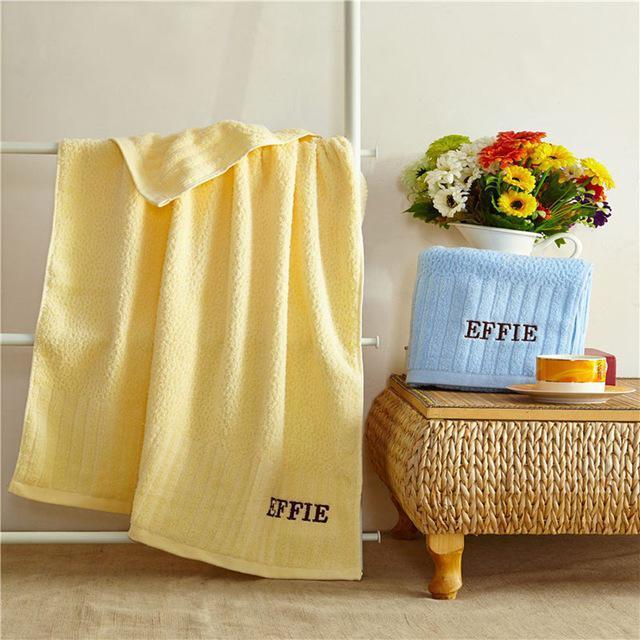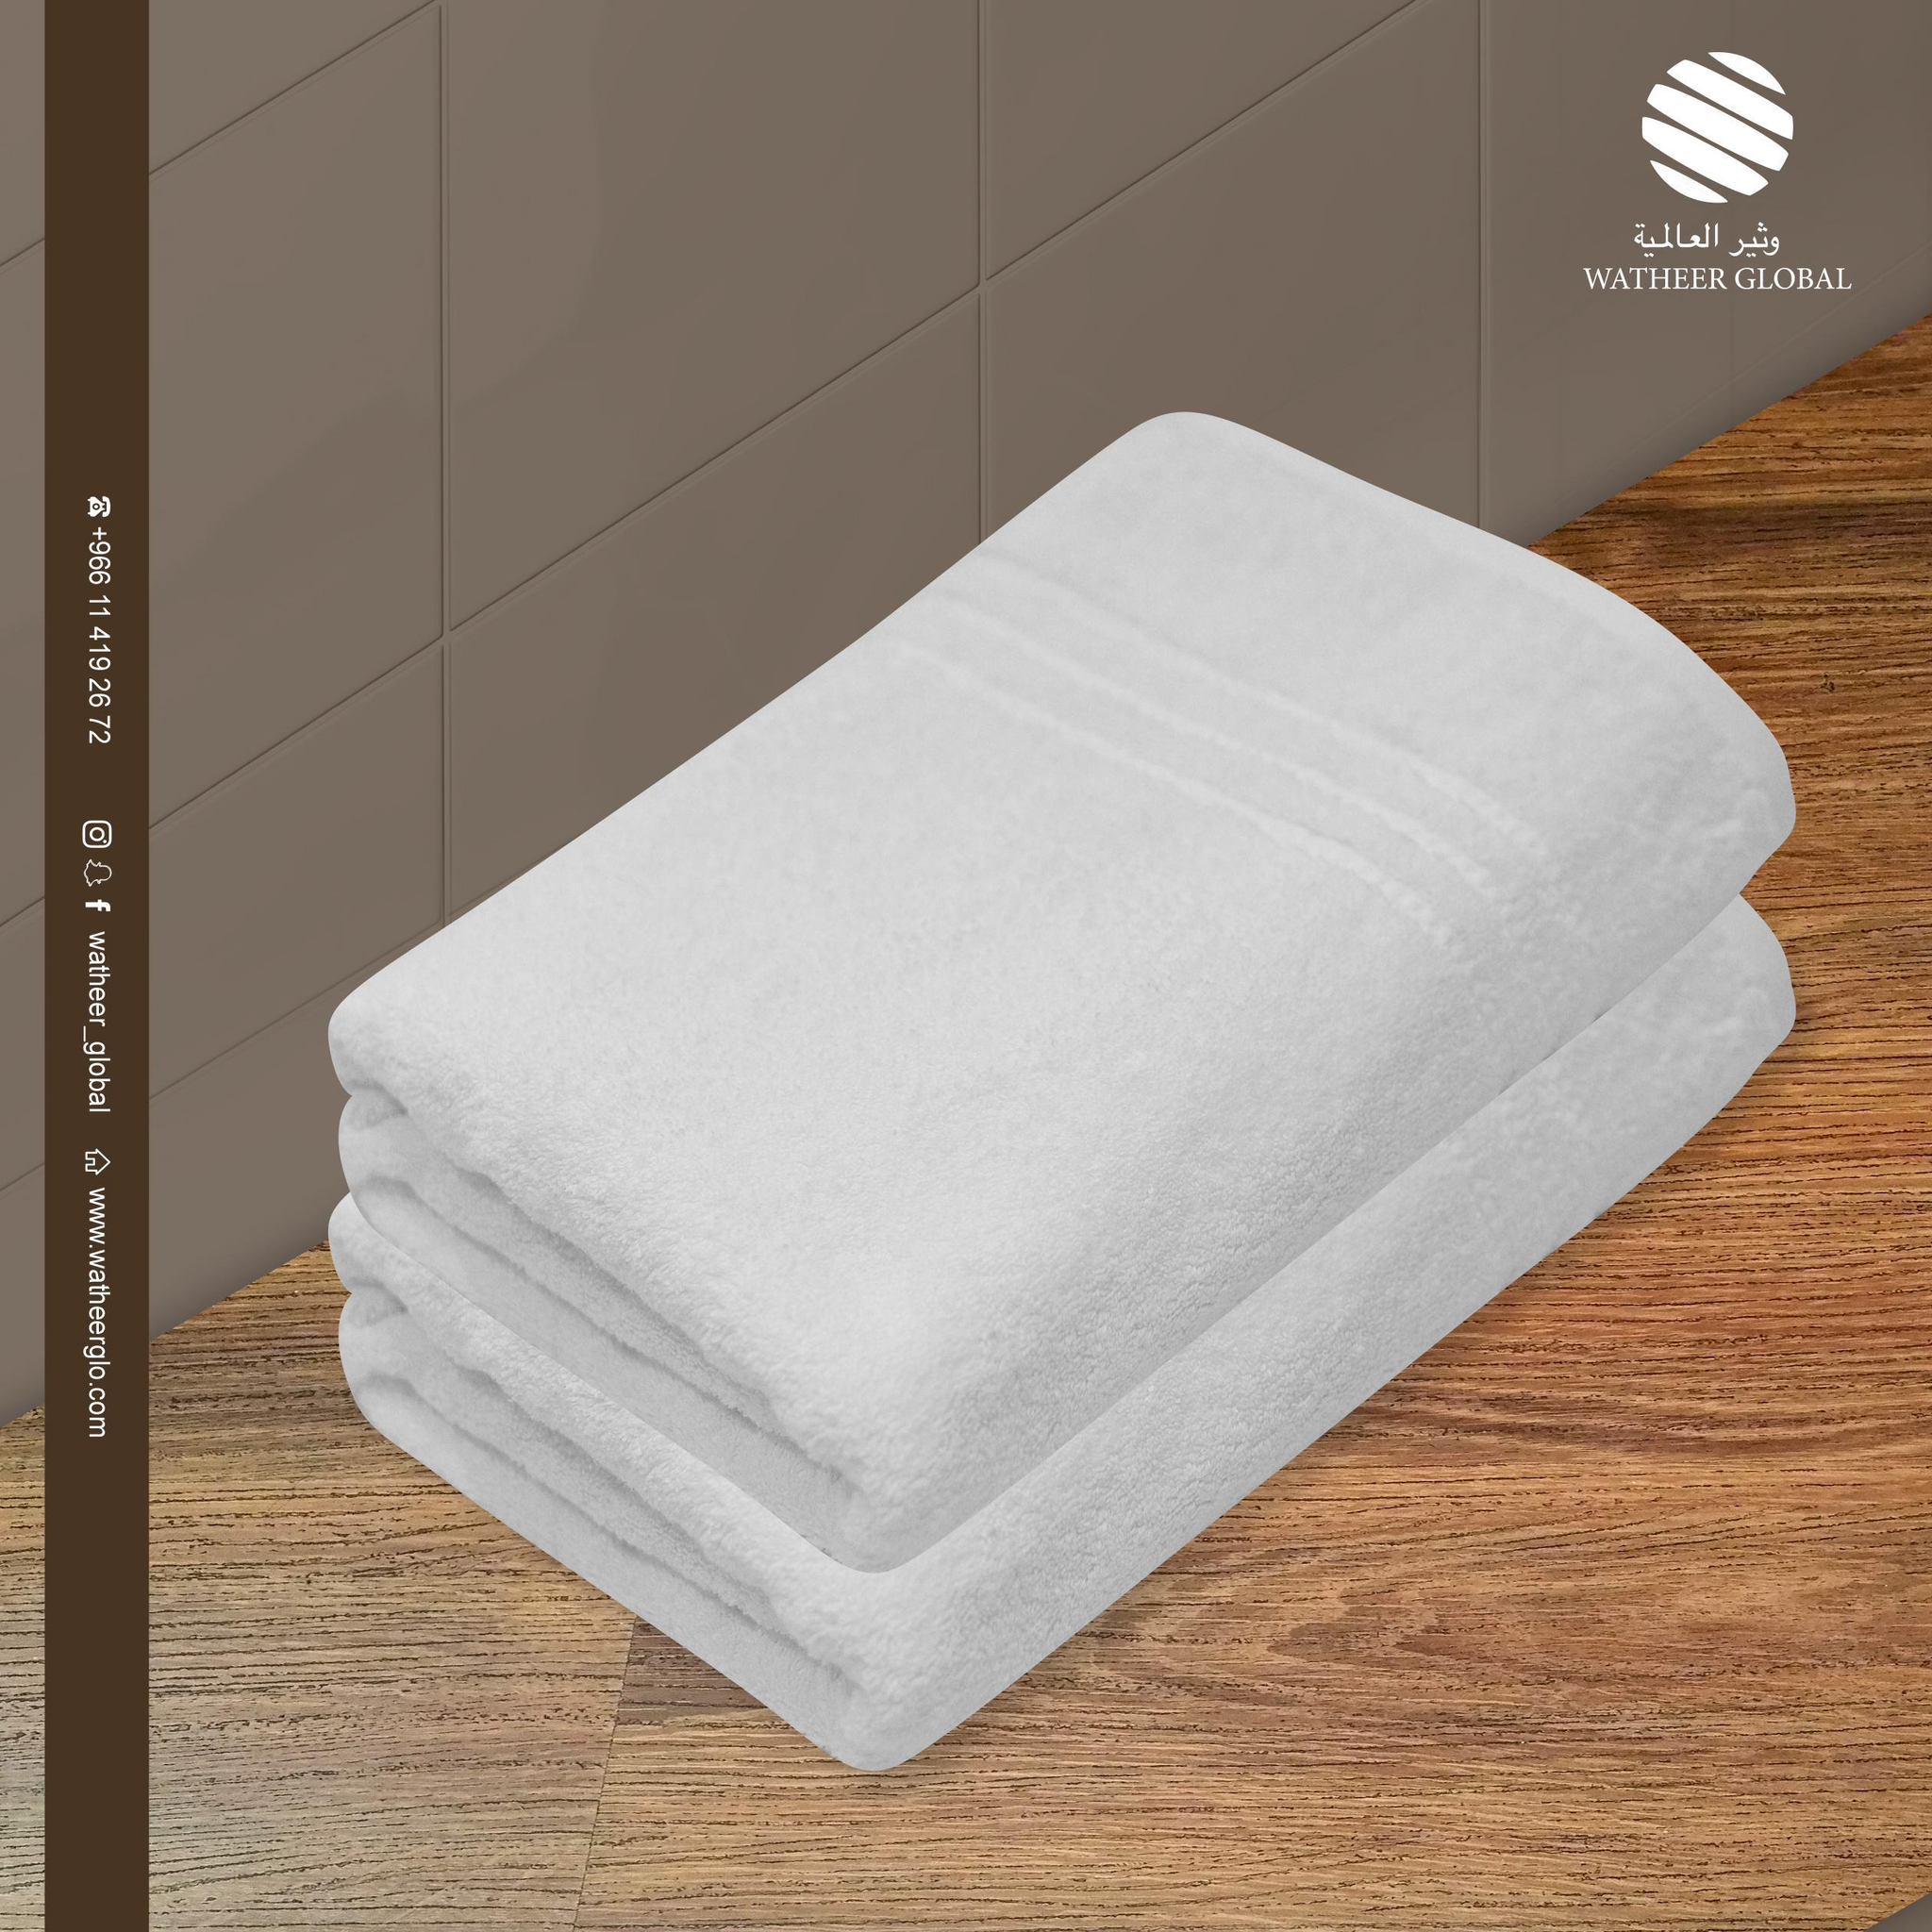The first image is the image on the left, the second image is the image on the right. For the images displayed, is the sentence "There is exactly one yellow towel." factually correct? Answer yes or no. Yes. The first image is the image on the left, the second image is the image on the right. Examine the images to the left and right. Is the description "There are exactly three folded towels in at least one image." accurate? Answer yes or no. No. 